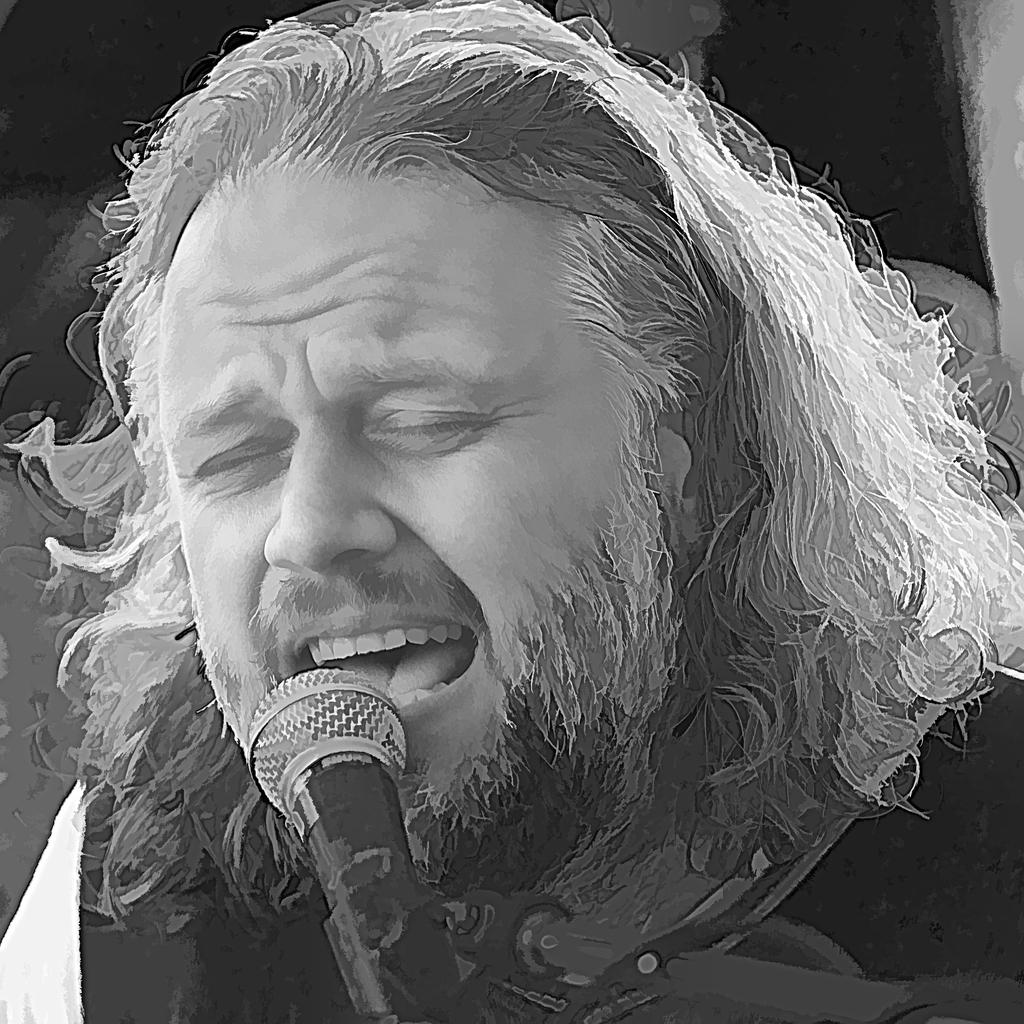What is the color scheme of the image? The image is black and white. Can you describe the main subject in the image? There is a person in the image. What object is visible near the person? There is a microphone in the image. How many leaves can be seen on the person in the image? There are no leaves present in the image; it features a person and a microphone in a black and white setting. 